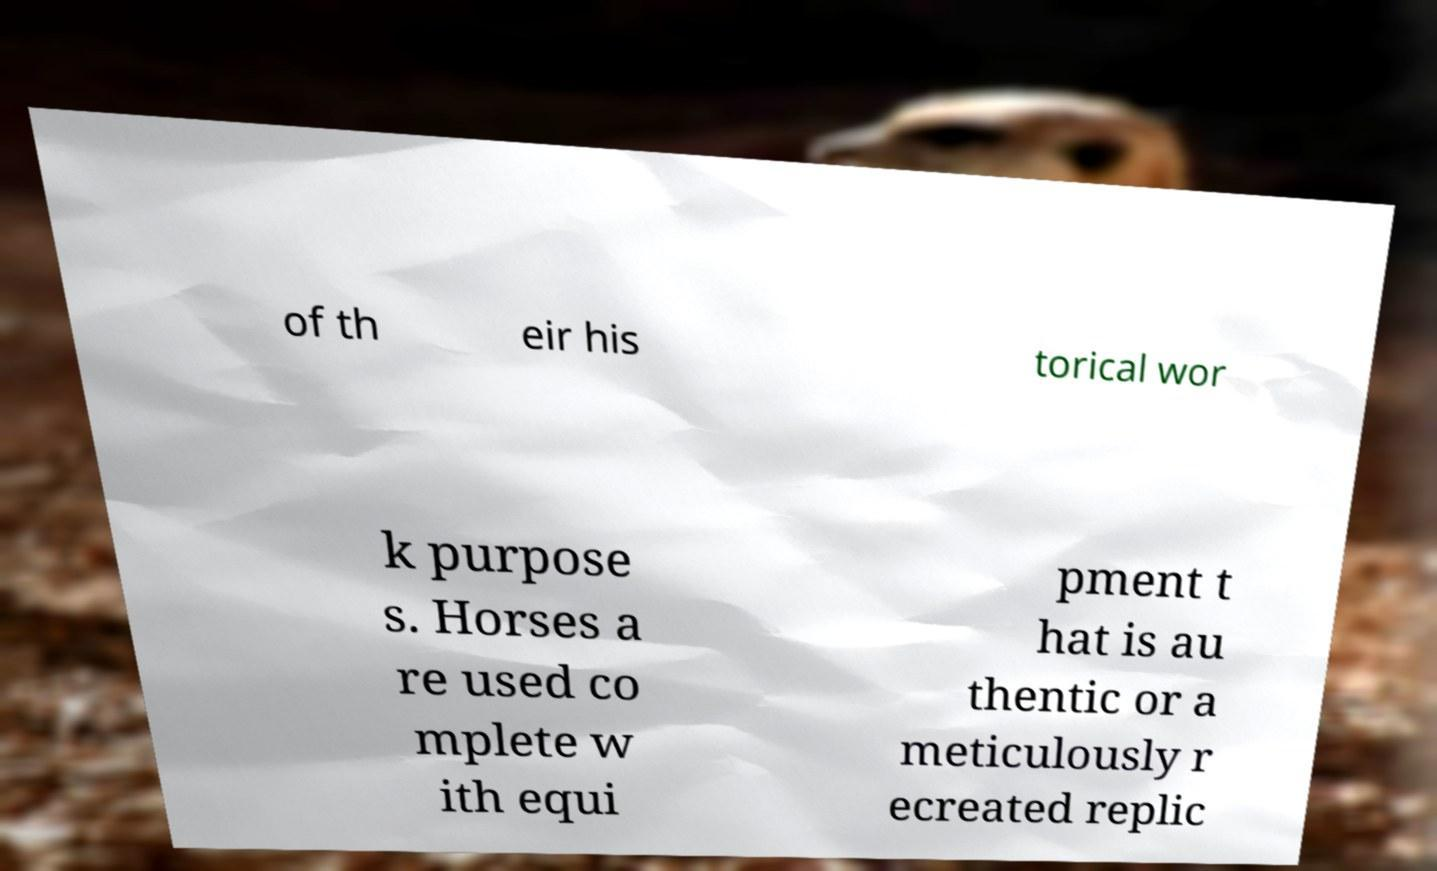Could you extract and type out the text from this image? of th eir his torical wor k purpose s. Horses a re used co mplete w ith equi pment t hat is au thentic or a meticulously r ecreated replic 